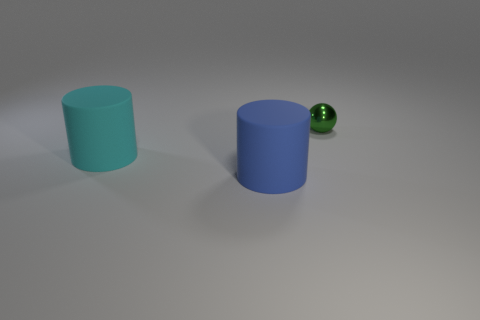Is there any other thing that has the same shape as the small thing?
Offer a very short reply. No. Are the green sphere and the big thing in front of the big cyan matte thing made of the same material?
Offer a terse response. No. How many things are either things right of the large blue object or small balls?
Provide a short and direct response. 1. There is a thing that is in front of the small sphere and behind the big blue rubber cylinder; what is its shape?
Offer a terse response. Cylinder. Is there anything else that is the same size as the blue rubber object?
Keep it short and to the point. Yes. What size is the blue object that is the same material as the large cyan object?
Provide a short and direct response. Large. What number of things are objects left of the sphere or large rubber things to the right of the large cyan matte thing?
Provide a succinct answer. 2. There is a cylinder that is behind the blue cylinder; is its size the same as the shiny sphere?
Provide a succinct answer. No. What is the color of the rubber cylinder that is in front of the cyan cylinder?
Make the answer very short. Blue. The other object that is the same shape as the big cyan object is what color?
Your answer should be compact. Blue. 